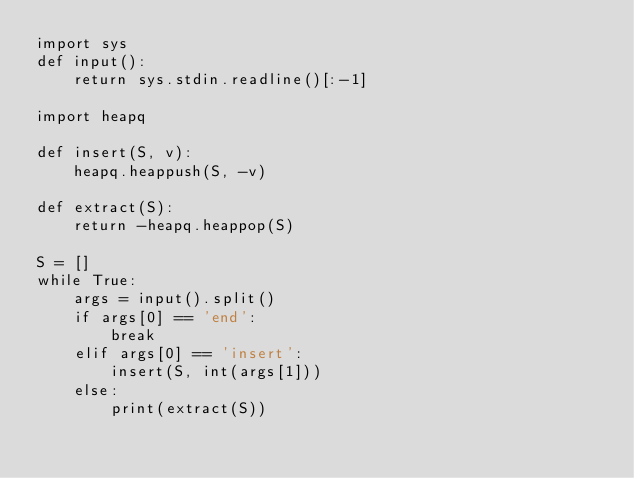Convert code to text. <code><loc_0><loc_0><loc_500><loc_500><_Python_>import sys
def input():
    return sys.stdin.readline()[:-1]

import heapq

def insert(S, v):
    heapq.heappush(S, -v)

def extract(S):
    return -heapq.heappop(S)

S = []
while True:
    args = input().split()
    if args[0] == 'end':
        break
    elif args[0] == 'insert':
        insert(S, int(args[1]))
    else:
        print(extract(S))
</code> 